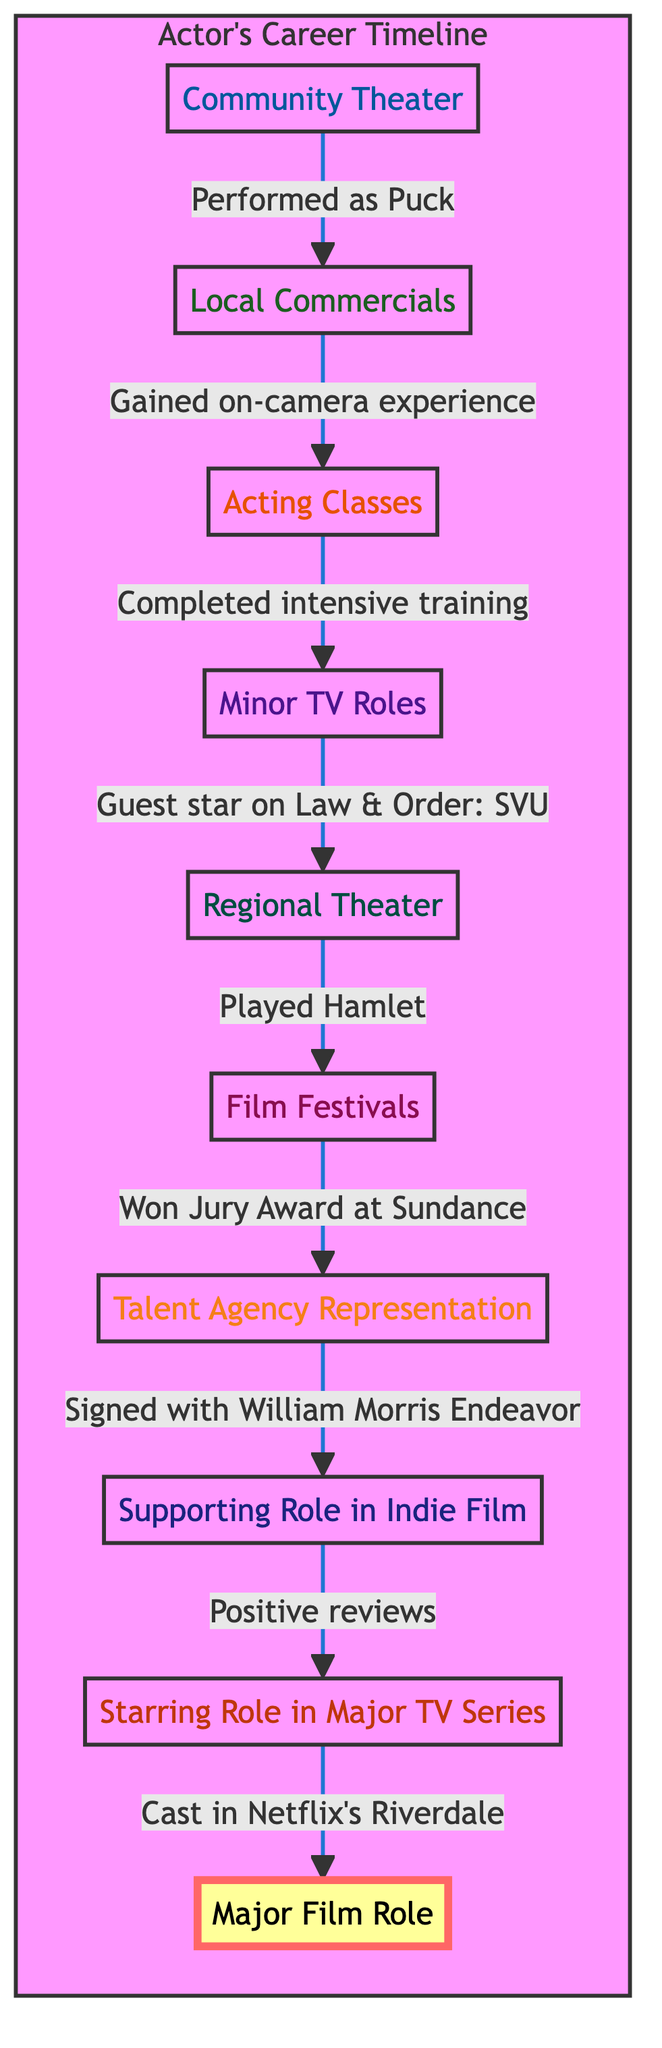What's the first stage in the actor's career timeline? The flowchart starts with the bottom node labeled "Community Theater," indicating it is the first stage in the actor's career progression.
Answer: Community Theater How many stages are there in the actor's career timeline? By counting the nodes in the flowchart, we find that there are a total of ten stages present in the timeline from community theater to a major film role.
Answer: 10 What achievement is associated with the 'Supporting Role in Indie Film'? The node labeled "Supporting Role in Indie Film" includes the specific achievement of receiving positive reviews for the portrayal of the character, which is mentioned directly underneath the node.
Answer: Positive reviews Which stage comes after 'Talent Agency Representation'? The flowchart shows an upward arrow leading from the "Talent Agency Representation" node to the next node labeled "Supporting Role in Indie Film," indicating this is the subsequent stage in the timeline.
Answer: Supporting Role in Indie Film What's the last milestone in the timeline? The flowchart identifies "Major Film Role," which is highlighted as a milestone node because it is marked distinctly within the diagram. It represents a significant advancement in the actor's career.
Answer: Major Film Role What acting role did the actor play in their community theater? The description under "Community Theater" specifies the performance as Puck in "A Midsummer Night's Dream," which identifies the particular role the actor played during this stage.
Answer: Puck in 'A Midsummer Night's Dream' Which major film did the actor secure a role in? At the top of the flowchart is the node "Major Film Role," which specifies the title of the film as "The Rising Star," identifying it as the major film the actor landed a role in.
Answer: The Rising Star What type of agency did the actor sign with? Under the "Talent Agency Representation" node, it is stated that the actor signed with the William Morris Endeavor talent agency, indicating the type of agency providing representation.
Answer: William Morris Endeavor Which stage involves acting classes? The flowchart describes the "Acting Classes" stage, which is directly after "Local Commercials" and includes details about enrollment in workshops at the Juilliard Summer Program.
Answer: Acting Classes 